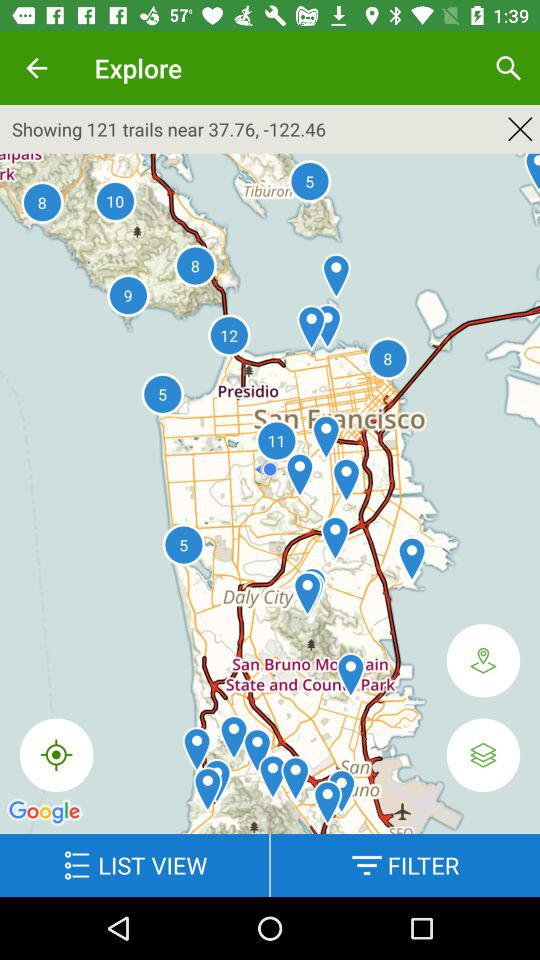How many trails are there? There are 121 trails. 